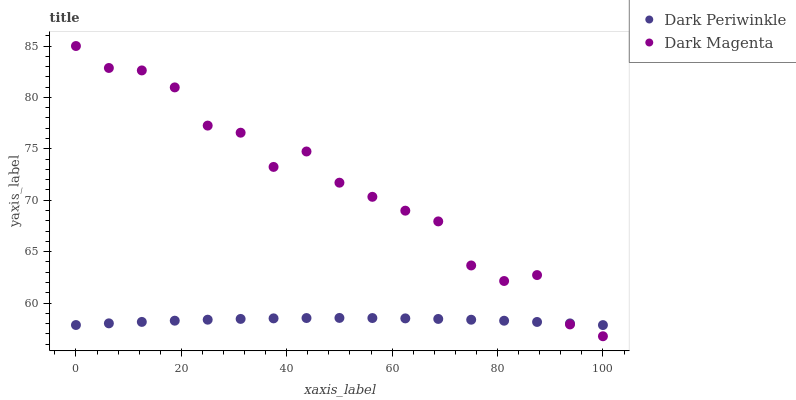Does Dark Periwinkle have the minimum area under the curve?
Answer yes or no. Yes. Does Dark Magenta have the maximum area under the curve?
Answer yes or no. Yes. Does Dark Magenta have the minimum area under the curve?
Answer yes or no. No. Is Dark Periwinkle the smoothest?
Answer yes or no. Yes. Is Dark Magenta the roughest?
Answer yes or no. Yes. Is Dark Magenta the smoothest?
Answer yes or no. No. Does Dark Magenta have the lowest value?
Answer yes or no. Yes. Does Dark Magenta have the highest value?
Answer yes or no. Yes. Does Dark Periwinkle intersect Dark Magenta?
Answer yes or no. Yes. Is Dark Periwinkle less than Dark Magenta?
Answer yes or no. No. Is Dark Periwinkle greater than Dark Magenta?
Answer yes or no. No. 